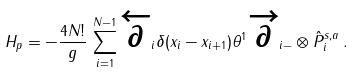Convert formula to latex. <formula><loc_0><loc_0><loc_500><loc_500>H _ { p } = - \frac { 4 N ! } { g } \, \sum _ { i = 1 } ^ { N - 1 } \overleftarrow { \partial } _ { i } \delta ( x _ { i } - x _ { i + 1 } ) \theta ^ { 1 } \overrightarrow { \partial } _ { i - } \otimes \hat { P } ^ { s , a } _ { i } \, .</formula> 